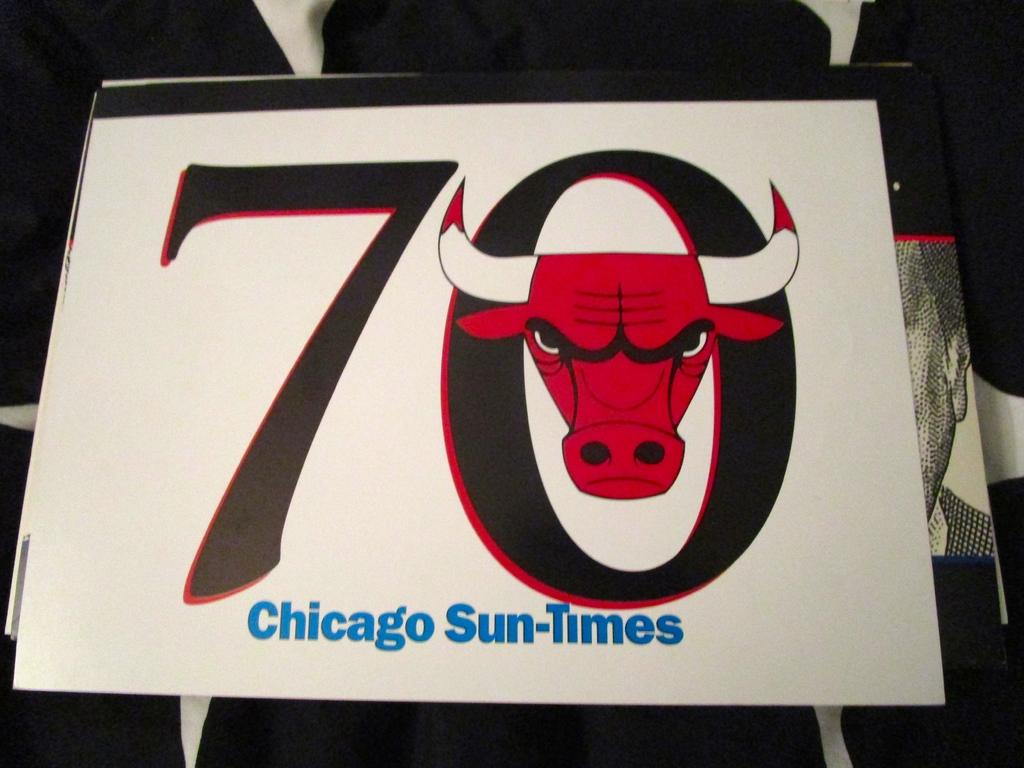What is the main object in the image? There is a board in the image. What is depicted on the board? The board contains a bull head. What else can be seen on the board besides the bull head? The board contains numbers and some text. What type of letter is the bull holding in its tongue in the image? There is no letter or tongue present in the image; the bull head is a depiction on the board. What type of bone can be seen sticking out of the bull's forehead in the image? There is no bone visible on the bull's forehead in the image; it is a depiction on the board. 